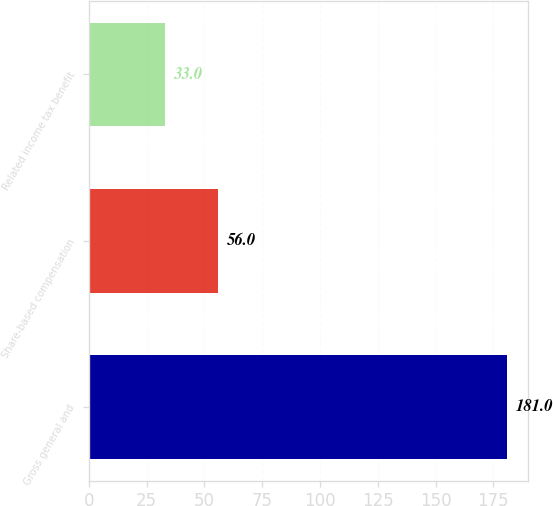Convert chart to OTSL. <chart><loc_0><loc_0><loc_500><loc_500><bar_chart><fcel>Gross general and<fcel>Share-based compensation<fcel>Related income tax benefit<nl><fcel>181<fcel>56<fcel>33<nl></chart> 